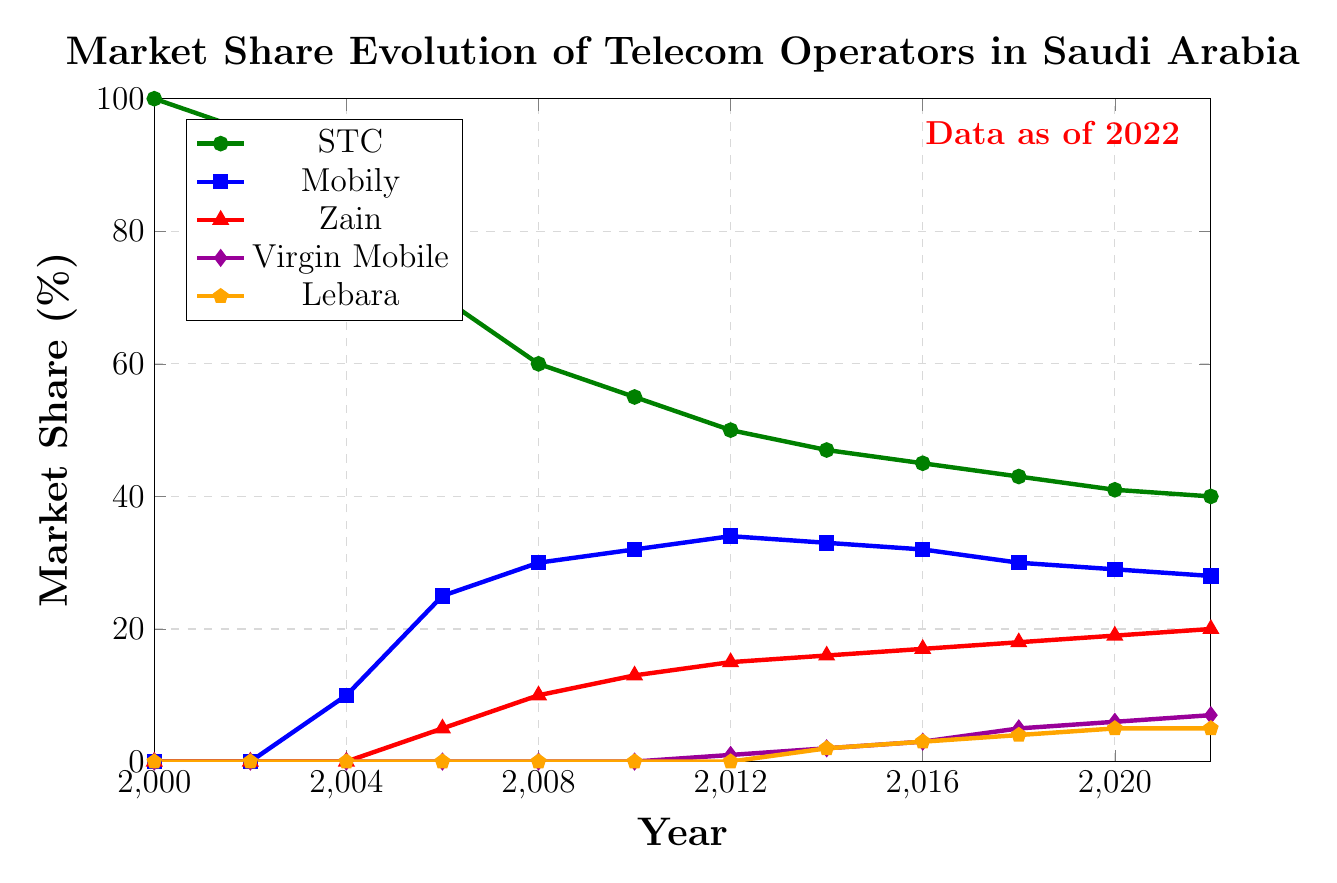What's the market share of Virgin Mobile in 2014? Locate the point in 2014 on the Virgin Mobile (purple diamond) line. The y-axis value at that point indicates the market share.
Answer: 2% How did Mobily's market share change from 2004 to 2008? Compare the y-axis values of Mobily (blue square) in 2004 and 2008. Mobily's market share increased from 10% in 2004 to 30% in 2008.
Answer: Increased by 20% Which operator had the highest market share in 2022? Look at the end points of each line at the year 2022. STC (green circle) has the highest market share among all operators.
Answer: STC What is the combined market share of Zain and Lebara in 2020? Locate the points in 2020 for Zain (red triangle) and Lebara (orange pentagon) lines. Add their values: 19% (Zain) + 5% (Lebara).
Answer: 24% Which operator shows the most significant decrease in market share from 2000 to 2022? Compare the starting and ending points of each line. STC (green circle) decreased from 100% in 2000 to 40% in 2022, which is the largest decrease.
Answer: STC What trend do you observe in Virgin Mobile's market share from 2012 to 2022? Analyze the points from 2012 to 2022 on the Virgin Mobile (purple diamond) line. The market share shows a steady increase from 1% in 2012 to 7% in 2022.
Answer: Increasing trend In which year did Zain first appear in the market, and what was its initial market share? Find the first non-zero point on the Zain (red triangle) line. Zain first appeared in 2006 with a market share of 5%.
Answer: 2006, 5% Did any operator reach a market share of 50% or more in 2014? If yes, which one? Compare the market shares of all operators in 2014. None of them reached 50% or more.
Answer: No How has STC's market share evolved between 2004 and 2010? Refer to the STC (green circle) line between 2004 and 2010. STC's market share decreased from 90% in 2004 to 55% in 2010.
Answer: Decreased by 35% What is the visual color representation of Lebara's market share? Identify the color used for the Lebara line (orange pentagon).
Answer: Orange 